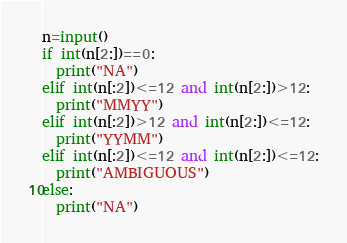Convert code to text. <code><loc_0><loc_0><loc_500><loc_500><_Python_>n=input()
if int(n[2:])==0:
  print("NA")
elif int(n[:2])<=12 and int(n[2:])>12:
  print("MMYY")
elif int(n[:2])>12 and int(n[2:])<=12:
  print("YYMM")
elif int(n[:2])<=12 and int(n[2:])<=12:
  print("AMBIGUOUS")
else:
  print("NA")</code> 